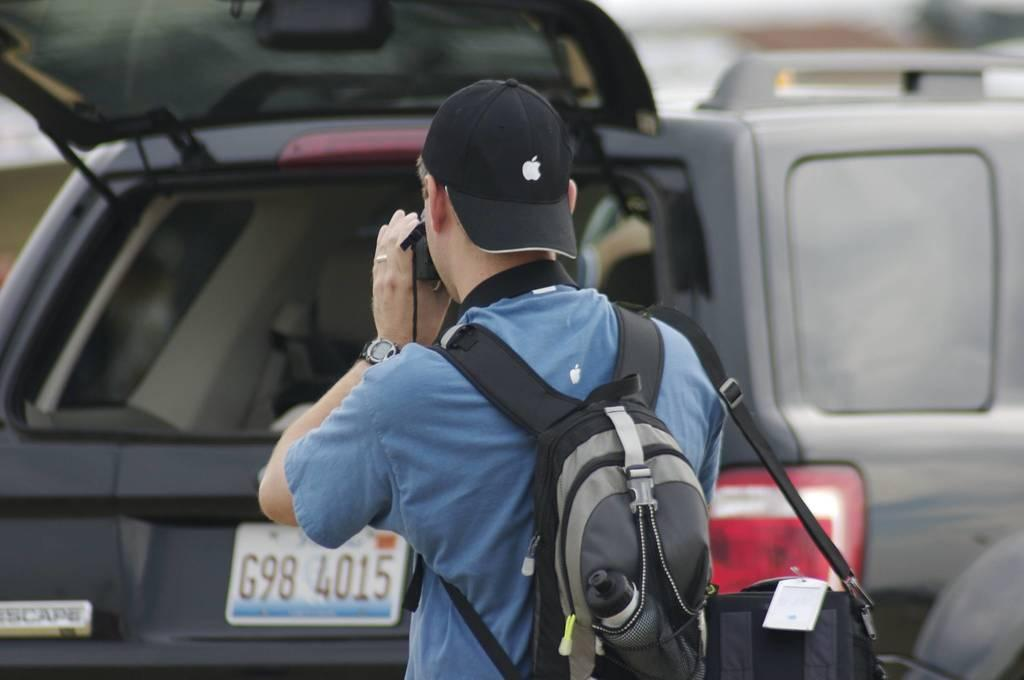Who is present in the image? There is a man in the image. What is the man wearing on his head? The man is wearing a hat. What is the man carrying in his hand? The man is carrying a bag. What is the man holding in his other hand? The man is holding a camera. What can be seen in the distance in the image? There are vehicles visible in the background of the image. What type of brass instrument is the man playing in the image? There is no brass instrument present in the image. 